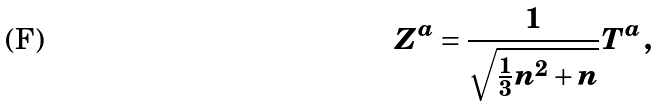Convert formula to latex. <formula><loc_0><loc_0><loc_500><loc_500>Z ^ { a } = \frac { 1 } { \sqrt { \frac { 1 } { 3 } n ^ { 2 } + n } } T ^ { a } \, ,</formula> 